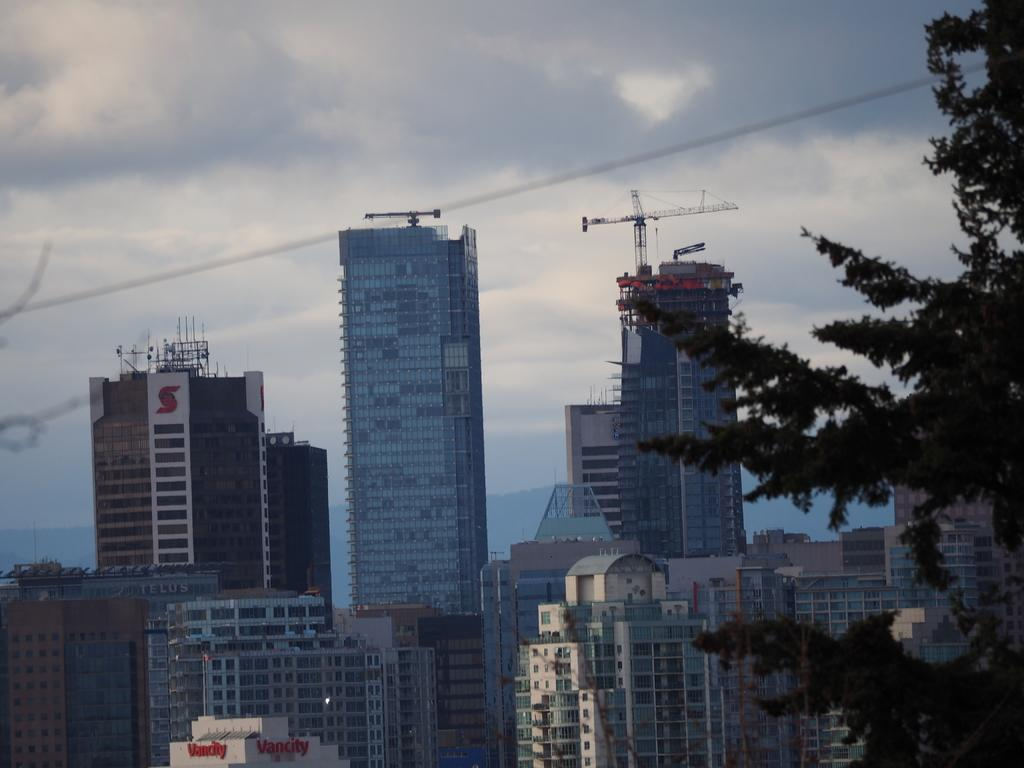What type of structures can be seen in the image? There are buildings in the image. What type of vegetation is present in the image? There are trees in the image. What language is spoken by the trees in the image? Trees do not speak any language, so this question cannot be answered. 